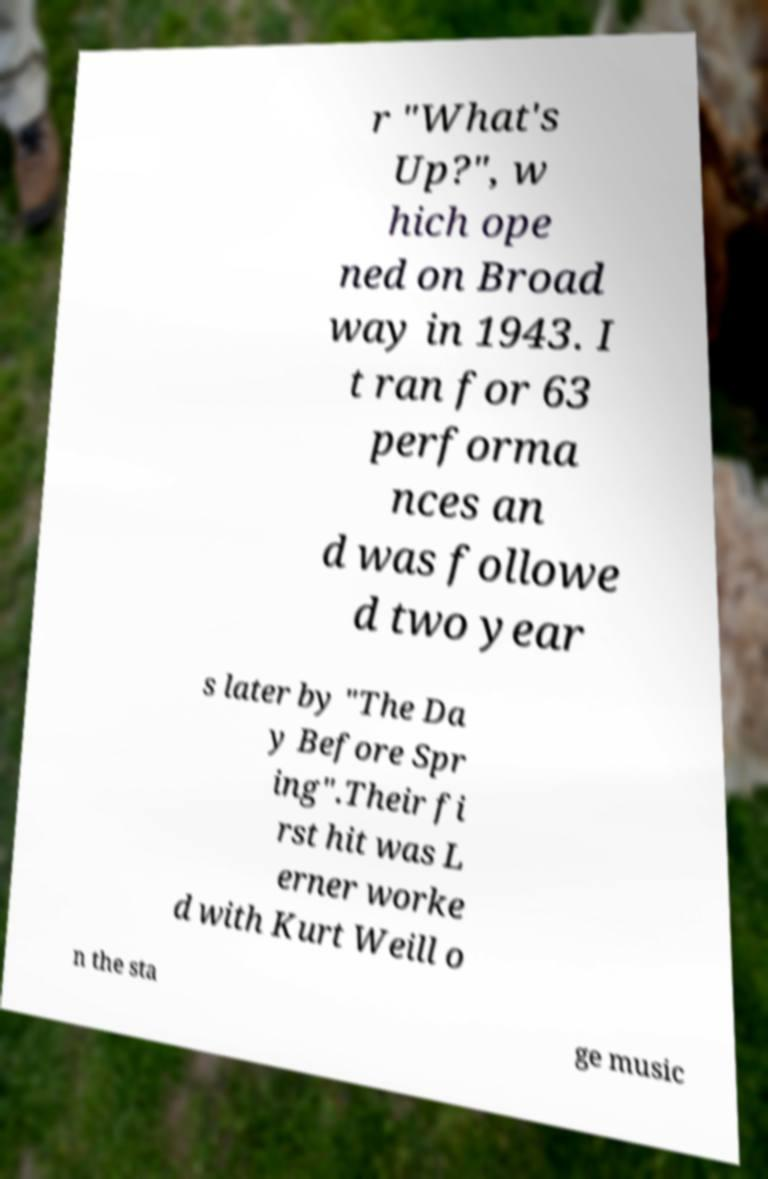Could you extract and type out the text from this image? r "What's Up?", w hich ope ned on Broad way in 1943. I t ran for 63 performa nces an d was followe d two year s later by "The Da y Before Spr ing".Their fi rst hit was L erner worke d with Kurt Weill o n the sta ge music 